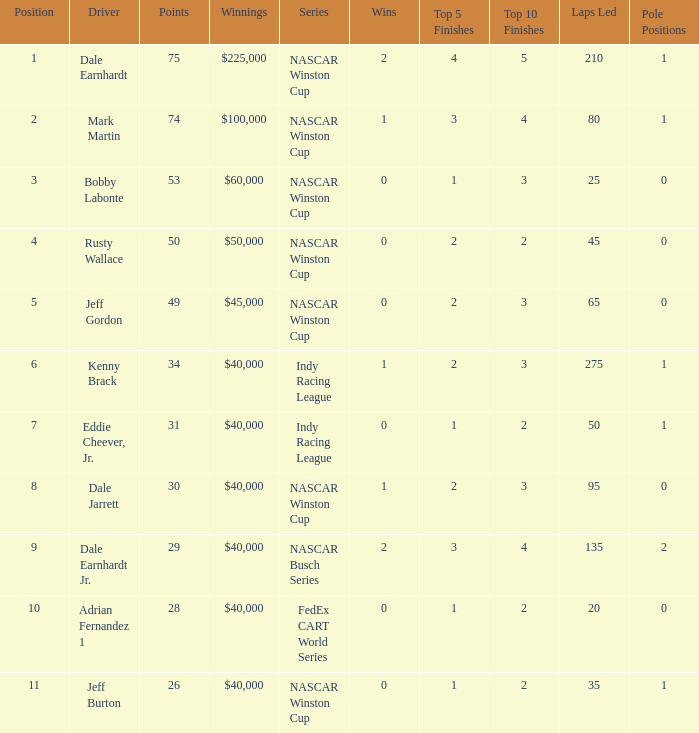How much did Jeff Burton win? $40,000. Could you parse the entire table? {'header': ['Position', 'Driver', 'Points', 'Winnings', 'Series', 'Wins', 'Top 5 Finishes', 'Top 10 Finishes', 'Laps Led', 'Pole Positions'], 'rows': [['1', 'Dale Earnhardt', '75', '$225,000', 'NASCAR Winston Cup', '2', '4', '5', '210', '1'], ['2', 'Mark Martin', '74', '$100,000', 'NASCAR Winston Cup', '1', '3', '4', '80', '1'], ['3', 'Bobby Labonte', '53', '$60,000', 'NASCAR Winston Cup', '0', '1', '3', '25', '0'], ['4', 'Rusty Wallace', '50', '$50,000', 'NASCAR Winston Cup', '0', '2', '2', '45', '0'], ['5', 'Jeff Gordon', '49', '$45,000', 'NASCAR Winston Cup', '0', '2', '3', '65', '0'], ['6', 'Kenny Brack', '34', '$40,000', 'Indy Racing League', '1', '2', '3', '275', '1'], ['7', 'Eddie Cheever, Jr.', '31', '$40,000', 'Indy Racing League', '0', '1', '2', '50', '1'], ['8', 'Dale Jarrett', '30', '$40,000', 'NASCAR Winston Cup', '1', '2', '3', '95', '0'], ['9', 'Dale Earnhardt Jr.', '29', '$40,000', 'NASCAR Busch Series', '2', '3', '4', '135', '2'], ['10', 'Adrian Fernandez 1', '28', '$40,000', 'FedEx CART World Series', '0', '1', '2', '20', '0'], ['11', 'Jeff Burton', '26', '$40,000', 'NASCAR Winston Cup', '0', '1', '2', '35', '1']]} 